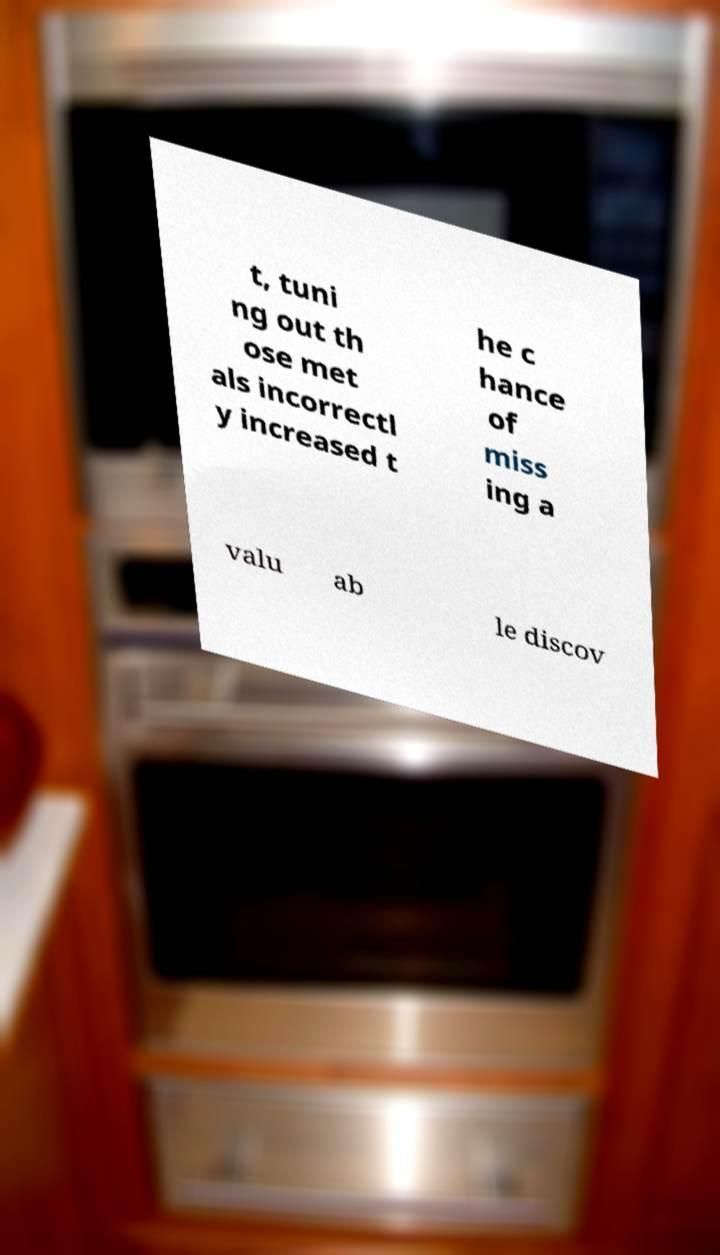Can you read and provide the text displayed in the image?This photo seems to have some interesting text. Can you extract and type it out for me? t, tuni ng out th ose met als incorrectl y increased t he c hance of miss ing a valu ab le discov 